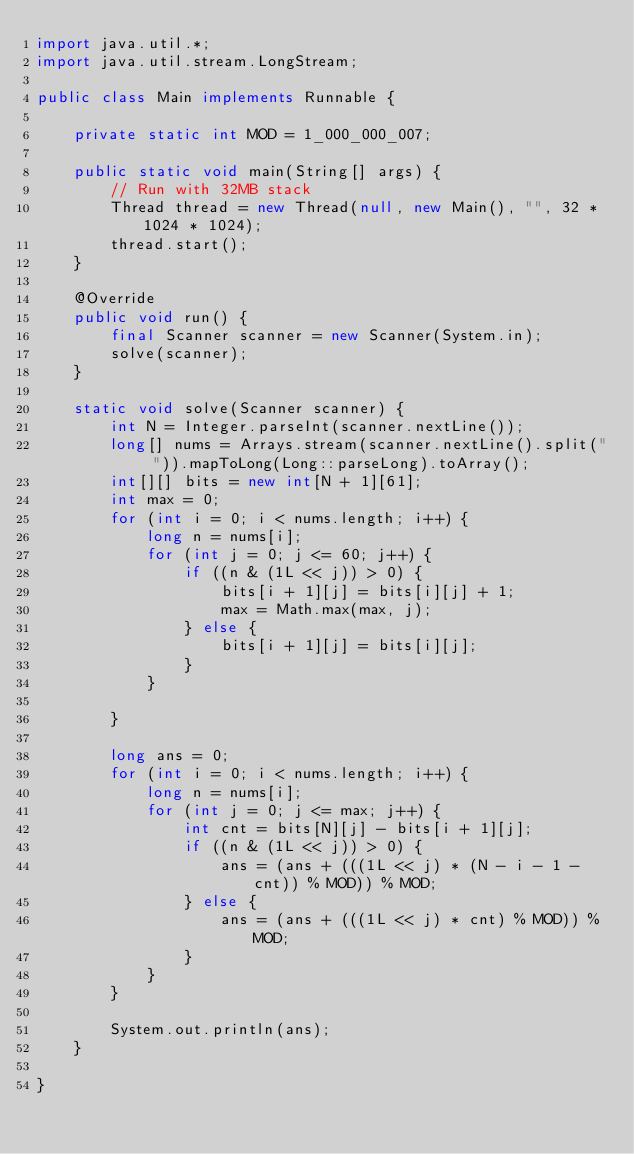<code> <loc_0><loc_0><loc_500><loc_500><_Java_>import java.util.*;
import java.util.stream.LongStream;

public class Main implements Runnable {

    private static int MOD = 1_000_000_007;

    public static void main(String[] args) {
        // Run with 32MB stack
        Thread thread = new Thread(null, new Main(), "", 32 * 1024 * 1024);
        thread.start();
    }

    @Override
    public void run() {
        final Scanner scanner = new Scanner(System.in);
        solve(scanner);
    }

    static void solve(Scanner scanner) {
        int N = Integer.parseInt(scanner.nextLine());
        long[] nums = Arrays.stream(scanner.nextLine().split(" ")).mapToLong(Long::parseLong).toArray();
        int[][] bits = new int[N + 1][61];
        int max = 0;
        for (int i = 0; i < nums.length; i++) {
            long n = nums[i];
            for (int j = 0; j <= 60; j++) {
                if ((n & (1L << j)) > 0) {
                    bits[i + 1][j] = bits[i][j] + 1;
                    max = Math.max(max, j);
                } else {
                    bits[i + 1][j] = bits[i][j];
                }
            }

        }

        long ans = 0;
        for (int i = 0; i < nums.length; i++) {
            long n = nums[i];
            for (int j = 0; j <= max; j++) {
                int cnt = bits[N][j] - bits[i + 1][j];
                if ((n & (1L << j)) > 0) {
                    ans = (ans + (((1L << j) * (N - i - 1 - cnt)) % MOD)) % MOD;
                } else {
                    ans = (ans + (((1L << j) * cnt) % MOD)) % MOD;
                }
            }
        }

        System.out.println(ans);
    }

}
</code> 